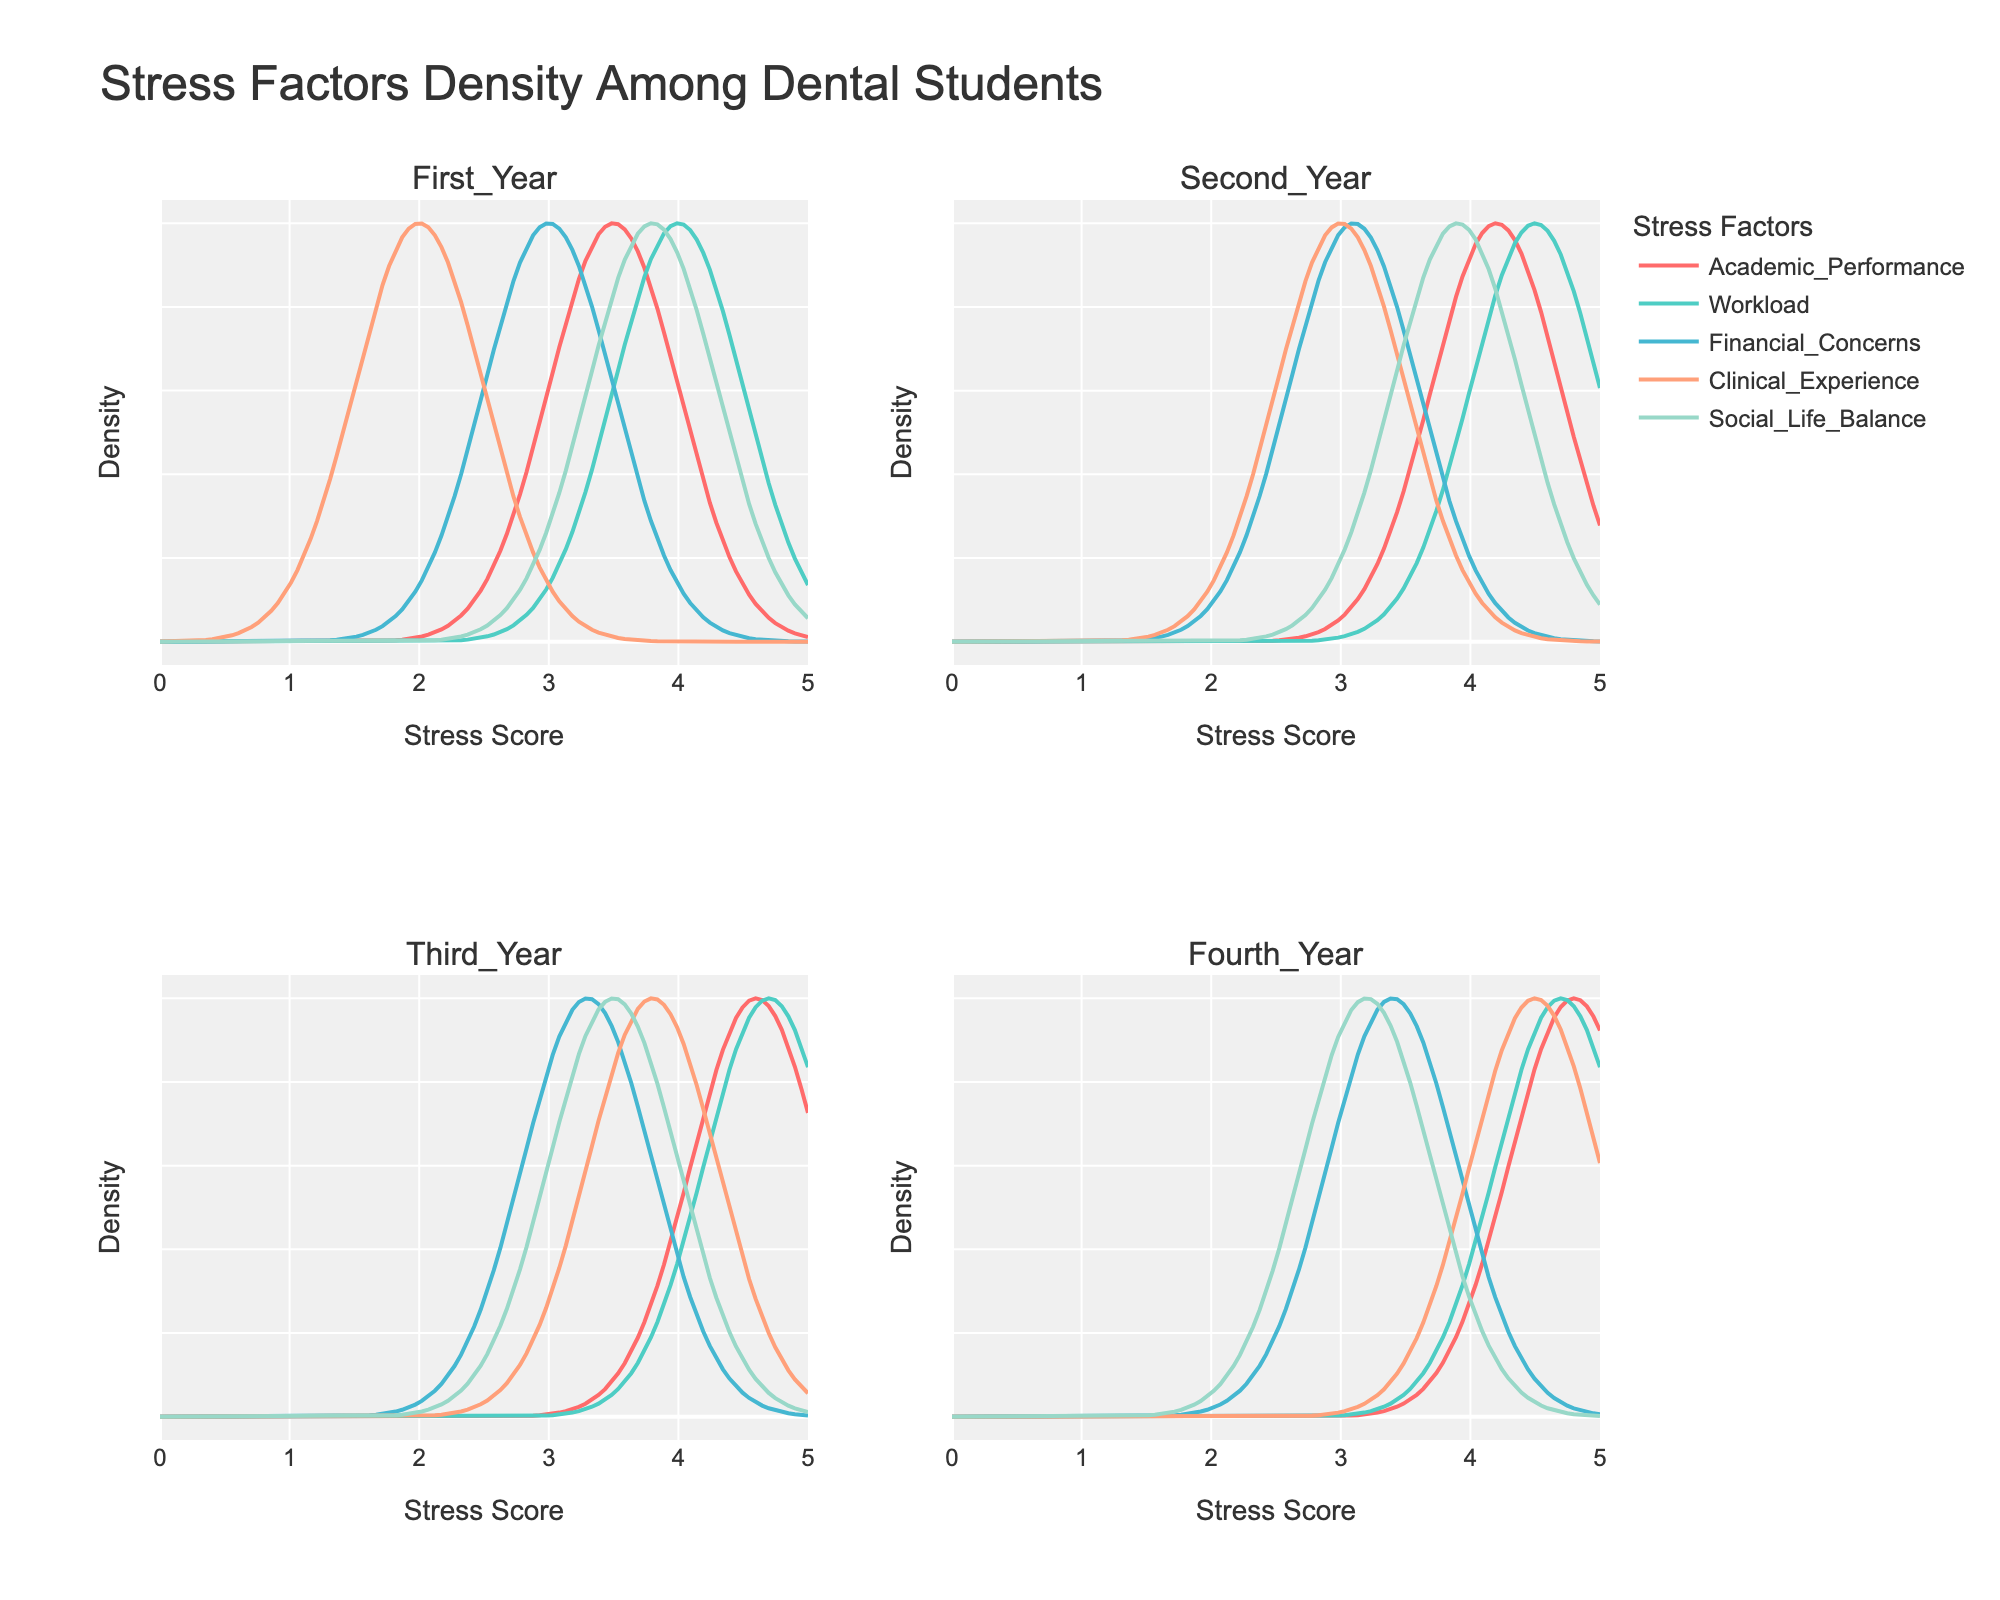What is the title of the figure? The title is usually displayed at the top of the figure. In this case, it is "Stress Factors Density Among Dental Students".
Answer: Stress Factors Density Among Dental Students ## How is the workload stress factor represented visually across different academic levels? Each stress factor is represented by a line with a specific color. By identifying the color associated with workload stress and tracing it across the subplots, we can see how it changes across first-year, second-year, third-year, and fourth-year students.
Answer: It is represented by a line in one of the colors: red, teal, blue, peach, or light green, appearing in all four subplots Which academic level experiences the highest academic performance stress score? By comparing the peak positions of the academic performance line in each subplot, we notice that the fourth-year students have the highest peak.
Answer: Fourth-year students How does the density of clinical experience stress compare between first-year and fourth-year students? By observing the heights and positions of the clinical experience stress lines in the first-year and fourth-year subplots, we can compare their densities. First-year students have lower peaks compared to fourth-year students.
Answer: Fourth-year students have higher density Among all academic levels, which stress factor has the lowest density? By scanning the lowest peaks in all the subplots, we see that the clinical experience stress factor has the lowest density, especially visible in the first-year subplot.
Answer: Clinical Experience What is the range of stress scores shown on the x-axis? The x-axis range is from 0 to 5, as indicated by the axis title and ticks.
Answer: 0 to 5 Which academic level has the most balanced social life stress score? By comparing the y-values (densities) of the social life factor across all subplots, the second year shows a relatively balanced (moderate peak) density.
Answer: Second-year students Is financial concern stress higher in third-year students compared to second-year students? By looking at the peaks of financial concerns lines in both third-year and second-year subplots, third-year students have a slightly higher peak than second-year students.
Answer: Yes Which stress factor appears to have the most consistent density across all academic levels? By analyzing the line heights and shapes for each stress factor across all subplots, academic performance shows a relatively consistent density across all academic levels.
Answer: Academic Performance What is the color representing the clinical experience stress factor, and how can you tell? By identifying the clinical experience stress factor label in the legend, it corresponds to a specific color which is then traced in each subplot.
Answer: Light green 